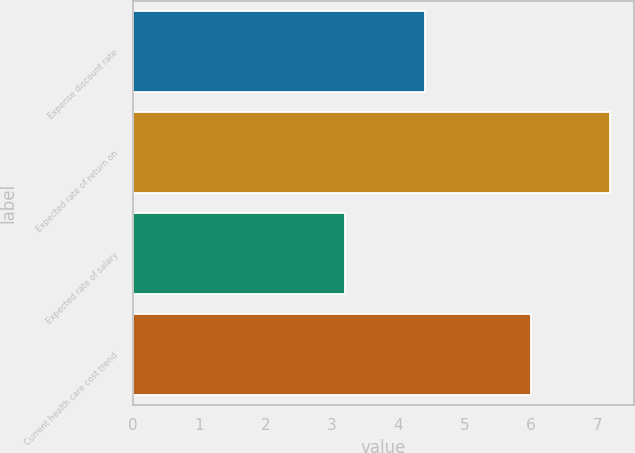Convert chart. <chart><loc_0><loc_0><loc_500><loc_500><bar_chart><fcel>Expense discount rate<fcel>Expected rate of return on<fcel>Expected rate of salary<fcel>Current health care cost trend<nl><fcel>4.4<fcel>7.2<fcel>3.2<fcel>6<nl></chart> 